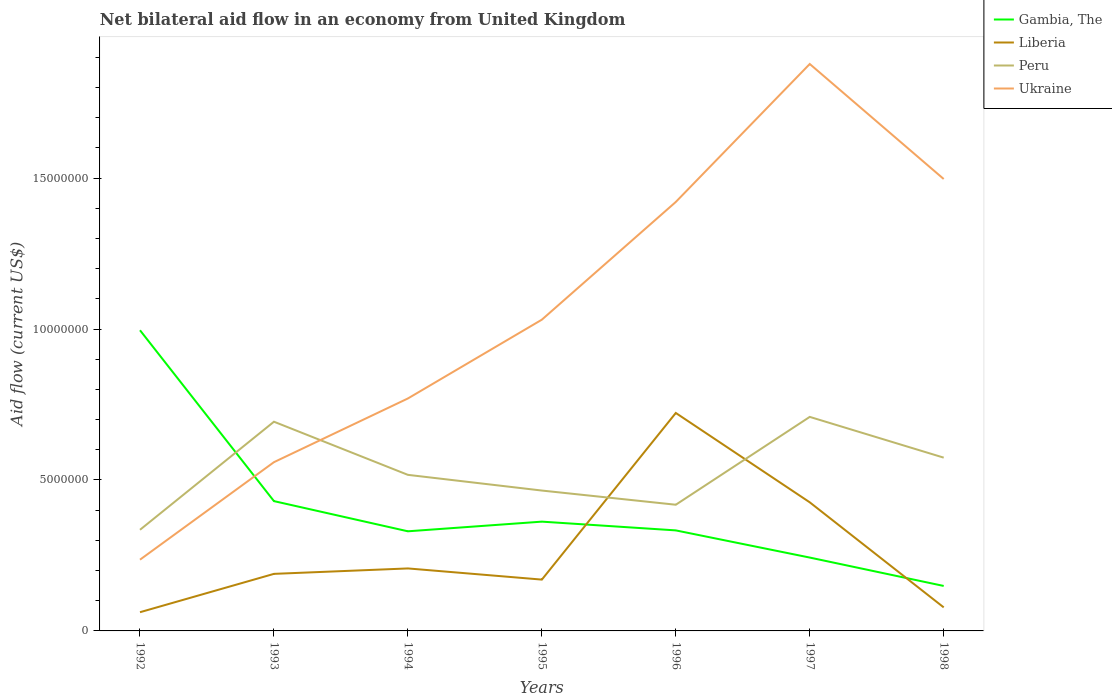Does the line corresponding to Ukraine intersect with the line corresponding to Gambia, The?
Keep it short and to the point. Yes. Across all years, what is the maximum net bilateral aid flow in Ukraine?
Make the answer very short. 2.36e+06. In which year was the net bilateral aid flow in Liberia maximum?
Keep it short and to the point. 1992. What is the total net bilateral aid flow in Liberia in the graph?
Your answer should be compact. -5.15e+06. What is the difference between the highest and the second highest net bilateral aid flow in Ukraine?
Make the answer very short. 1.64e+07. What is the difference between the highest and the lowest net bilateral aid flow in Liberia?
Provide a short and direct response. 2. Is the net bilateral aid flow in Gambia, The strictly greater than the net bilateral aid flow in Liberia over the years?
Your answer should be very brief. No. How many lines are there?
Offer a terse response. 4. Are the values on the major ticks of Y-axis written in scientific E-notation?
Make the answer very short. No. Does the graph contain any zero values?
Offer a terse response. No. How are the legend labels stacked?
Offer a terse response. Vertical. What is the title of the graph?
Offer a terse response. Net bilateral aid flow in an economy from United Kingdom. Does "Netherlands" appear as one of the legend labels in the graph?
Your response must be concise. No. What is the label or title of the Y-axis?
Give a very brief answer. Aid flow (current US$). What is the Aid flow (current US$) in Gambia, The in 1992?
Provide a succinct answer. 9.96e+06. What is the Aid flow (current US$) in Liberia in 1992?
Offer a terse response. 6.20e+05. What is the Aid flow (current US$) of Peru in 1992?
Make the answer very short. 3.35e+06. What is the Aid flow (current US$) in Ukraine in 1992?
Make the answer very short. 2.36e+06. What is the Aid flow (current US$) of Gambia, The in 1993?
Ensure brevity in your answer.  4.30e+06. What is the Aid flow (current US$) in Liberia in 1993?
Offer a terse response. 1.89e+06. What is the Aid flow (current US$) in Peru in 1993?
Offer a terse response. 6.93e+06. What is the Aid flow (current US$) in Ukraine in 1993?
Provide a short and direct response. 5.59e+06. What is the Aid flow (current US$) in Gambia, The in 1994?
Ensure brevity in your answer.  3.30e+06. What is the Aid flow (current US$) in Liberia in 1994?
Offer a terse response. 2.07e+06. What is the Aid flow (current US$) in Peru in 1994?
Give a very brief answer. 5.17e+06. What is the Aid flow (current US$) of Ukraine in 1994?
Ensure brevity in your answer.  7.70e+06. What is the Aid flow (current US$) in Gambia, The in 1995?
Give a very brief answer. 3.62e+06. What is the Aid flow (current US$) of Liberia in 1995?
Your answer should be very brief. 1.70e+06. What is the Aid flow (current US$) in Peru in 1995?
Ensure brevity in your answer.  4.65e+06. What is the Aid flow (current US$) of Ukraine in 1995?
Your answer should be very brief. 1.03e+07. What is the Aid flow (current US$) of Gambia, The in 1996?
Offer a terse response. 3.33e+06. What is the Aid flow (current US$) in Liberia in 1996?
Give a very brief answer. 7.22e+06. What is the Aid flow (current US$) in Peru in 1996?
Keep it short and to the point. 4.18e+06. What is the Aid flow (current US$) in Ukraine in 1996?
Your answer should be compact. 1.42e+07. What is the Aid flow (current US$) in Gambia, The in 1997?
Provide a short and direct response. 2.43e+06. What is the Aid flow (current US$) of Liberia in 1997?
Your answer should be very brief. 4.26e+06. What is the Aid flow (current US$) in Peru in 1997?
Ensure brevity in your answer.  7.09e+06. What is the Aid flow (current US$) in Ukraine in 1997?
Your answer should be compact. 1.88e+07. What is the Aid flow (current US$) of Gambia, The in 1998?
Provide a succinct answer. 1.49e+06. What is the Aid flow (current US$) of Liberia in 1998?
Give a very brief answer. 7.80e+05. What is the Aid flow (current US$) in Peru in 1998?
Your response must be concise. 5.74e+06. What is the Aid flow (current US$) of Ukraine in 1998?
Provide a short and direct response. 1.50e+07. Across all years, what is the maximum Aid flow (current US$) in Gambia, The?
Offer a very short reply. 9.96e+06. Across all years, what is the maximum Aid flow (current US$) of Liberia?
Make the answer very short. 7.22e+06. Across all years, what is the maximum Aid flow (current US$) of Peru?
Your answer should be very brief. 7.09e+06. Across all years, what is the maximum Aid flow (current US$) in Ukraine?
Your answer should be very brief. 1.88e+07. Across all years, what is the minimum Aid flow (current US$) of Gambia, The?
Offer a terse response. 1.49e+06. Across all years, what is the minimum Aid flow (current US$) in Liberia?
Make the answer very short. 6.20e+05. Across all years, what is the minimum Aid flow (current US$) in Peru?
Your response must be concise. 3.35e+06. Across all years, what is the minimum Aid flow (current US$) of Ukraine?
Ensure brevity in your answer.  2.36e+06. What is the total Aid flow (current US$) in Gambia, The in the graph?
Your answer should be compact. 2.84e+07. What is the total Aid flow (current US$) of Liberia in the graph?
Offer a very short reply. 1.85e+07. What is the total Aid flow (current US$) of Peru in the graph?
Your answer should be compact. 3.71e+07. What is the total Aid flow (current US$) in Ukraine in the graph?
Your answer should be compact. 7.39e+07. What is the difference between the Aid flow (current US$) in Gambia, The in 1992 and that in 1993?
Your response must be concise. 5.66e+06. What is the difference between the Aid flow (current US$) in Liberia in 1992 and that in 1993?
Offer a very short reply. -1.27e+06. What is the difference between the Aid flow (current US$) in Peru in 1992 and that in 1993?
Offer a very short reply. -3.58e+06. What is the difference between the Aid flow (current US$) in Ukraine in 1992 and that in 1993?
Offer a very short reply. -3.23e+06. What is the difference between the Aid flow (current US$) in Gambia, The in 1992 and that in 1994?
Give a very brief answer. 6.66e+06. What is the difference between the Aid flow (current US$) in Liberia in 1992 and that in 1994?
Your response must be concise. -1.45e+06. What is the difference between the Aid flow (current US$) of Peru in 1992 and that in 1994?
Provide a succinct answer. -1.82e+06. What is the difference between the Aid flow (current US$) of Ukraine in 1992 and that in 1994?
Ensure brevity in your answer.  -5.34e+06. What is the difference between the Aid flow (current US$) of Gambia, The in 1992 and that in 1995?
Give a very brief answer. 6.34e+06. What is the difference between the Aid flow (current US$) in Liberia in 1992 and that in 1995?
Provide a short and direct response. -1.08e+06. What is the difference between the Aid flow (current US$) in Peru in 1992 and that in 1995?
Offer a terse response. -1.30e+06. What is the difference between the Aid flow (current US$) of Ukraine in 1992 and that in 1995?
Offer a very short reply. -7.95e+06. What is the difference between the Aid flow (current US$) of Gambia, The in 1992 and that in 1996?
Offer a terse response. 6.63e+06. What is the difference between the Aid flow (current US$) of Liberia in 1992 and that in 1996?
Keep it short and to the point. -6.60e+06. What is the difference between the Aid flow (current US$) of Peru in 1992 and that in 1996?
Give a very brief answer. -8.30e+05. What is the difference between the Aid flow (current US$) of Ukraine in 1992 and that in 1996?
Your answer should be very brief. -1.18e+07. What is the difference between the Aid flow (current US$) of Gambia, The in 1992 and that in 1997?
Your answer should be very brief. 7.53e+06. What is the difference between the Aid flow (current US$) of Liberia in 1992 and that in 1997?
Your response must be concise. -3.64e+06. What is the difference between the Aid flow (current US$) in Peru in 1992 and that in 1997?
Keep it short and to the point. -3.74e+06. What is the difference between the Aid flow (current US$) in Ukraine in 1992 and that in 1997?
Provide a short and direct response. -1.64e+07. What is the difference between the Aid flow (current US$) of Gambia, The in 1992 and that in 1998?
Your answer should be compact. 8.47e+06. What is the difference between the Aid flow (current US$) of Peru in 1992 and that in 1998?
Your answer should be compact. -2.39e+06. What is the difference between the Aid flow (current US$) in Ukraine in 1992 and that in 1998?
Give a very brief answer. -1.26e+07. What is the difference between the Aid flow (current US$) in Peru in 1993 and that in 1994?
Your answer should be compact. 1.76e+06. What is the difference between the Aid flow (current US$) in Ukraine in 1993 and that in 1994?
Provide a short and direct response. -2.11e+06. What is the difference between the Aid flow (current US$) of Gambia, The in 1993 and that in 1995?
Give a very brief answer. 6.80e+05. What is the difference between the Aid flow (current US$) of Liberia in 1993 and that in 1995?
Give a very brief answer. 1.90e+05. What is the difference between the Aid flow (current US$) in Peru in 1993 and that in 1995?
Your answer should be very brief. 2.28e+06. What is the difference between the Aid flow (current US$) in Ukraine in 1993 and that in 1995?
Ensure brevity in your answer.  -4.72e+06. What is the difference between the Aid flow (current US$) in Gambia, The in 1993 and that in 1996?
Your response must be concise. 9.70e+05. What is the difference between the Aid flow (current US$) of Liberia in 1993 and that in 1996?
Keep it short and to the point. -5.33e+06. What is the difference between the Aid flow (current US$) in Peru in 1993 and that in 1996?
Your response must be concise. 2.75e+06. What is the difference between the Aid flow (current US$) in Ukraine in 1993 and that in 1996?
Ensure brevity in your answer.  -8.62e+06. What is the difference between the Aid flow (current US$) in Gambia, The in 1993 and that in 1997?
Offer a terse response. 1.87e+06. What is the difference between the Aid flow (current US$) of Liberia in 1993 and that in 1997?
Provide a short and direct response. -2.37e+06. What is the difference between the Aid flow (current US$) in Ukraine in 1993 and that in 1997?
Provide a succinct answer. -1.32e+07. What is the difference between the Aid flow (current US$) of Gambia, The in 1993 and that in 1998?
Your answer should be compact. 2.81e+06. What is the difference between the Aid flow (current US$) in Liberia in 1993 and that in 1998?
Make the answer very short. 1.11e+06. What is the difference between the Aid flow (current US$) in Peru in 1993 and that in 1998?
Give a very brief answer. 1.19e+06. What is the difference between the Aid flow (current US$) in Ukraine in 1993 and that in 1998?
Provide a short and direct response. -9.38e+06. What is the difference between the Aid flow (current US$) of Gambia, The in 1994 and that in 1995?
Keep it short and to the point. -3.20e+05. What is the difference between the Aid flow (current US$) in Peru in 1994 and that in 1995?
Keep it short and to the point. 5.20e+05. What is the difference between the Aid flow (current US$) of Ukraine in 1994 and that in 1995?
Keep it short and to the point. -2.61e+06. What is the difference between the Aid flow (current US$) in Gambia, The in 1994 and that in 1996?
Provide a succinct answer. -3.00e+04. What is the difference between the Aid flow (current US$) of Liberia in 1994 and that in 1996?
Offer a very short reply. -5.15e+06. What is the difference between the Aid flow (current US$) in Peru in 1994 and that in 1996?
Provide a short and direct response. 9.90e+05. What is the difference between the Aid flow (current US$) of Ukraine in 1994 and that in 1996?
Make the answer very short. -6.51e+06. What is the difference between the Aid flow (current US$) of Gambia, The in 1994 and that in 1997?
Offer a very short reply. 8.70e+05. What is the difference between the Aid flow (current US$) in Liberia in 1994 and that in 1997?
Your answer should be very brief. -2.19e+06. What is the difference between the Aid flow (current US$) in Peru in 1994 and that in 1997?
Ensure brevity in your answer.  -1.92e+06. What is the difference between the Aid flow (current US$) of Ukraine in 1994 and that in 1997?
Provide a short and direct response. -1.11e+07. What is the difference between the Aid flow (current US$) in Gambia, The in 1994 and that in 1998?
Offer a terse response. 1.81e+06. What is the difference between the Aid flow (current US$) of Liberia in 1994 and that in 1998?
Your answer should be compact. 1.29e+06. What is the difference between the Aid flow (current US$) in Peru in 1994 and that in 1998?
Provide a succinct answer. -5.70e+05. What is the difference between the Aid flow (current US$) of Ukraine in 1994 and that in 1998?
Keep it short and to the point. -7.27e+06. What is the difference between the Aid flow (current US$) in Liberia in 1995 and that in 1996?
Make the answer very short. -5.52e+06. What is the difference between the Aid flow (current US$) of Ukraine in 1995 and that in 1996?
Your answer should be very brief. -3.90e+06. What is the difference between the Aid flow (current US$) of Gambia, The in 1995 and that in 1997?
Make the answer very short. 1.19e+06. What is the difference between the Aid flow (current US$) of Liberia in 1995 and that in 1997?
Provide a short and direct response. -2.56e+06. What is the difference between the Aid flow (current US$) in Peru in 1995 and that in 1997?
Offer a very short reply. -2.44e+06. What is the difference between the Aid flow (current US$) of Ukraine in 1995 and that in 1997?
Your answer should be very brief. -8.47e+06. What is the difference between the Aid flow (current US$) of Gambia, The in 1995 and that in 1998?
Offer a very short reply. 2.13e+06. What is the difference between the Aid flow (current US$) of Liberia in 1995 and that in 1998?
Give a very brief answer. 9.20e+05. What is the difference between the Aid flow (current US$) in Peru in 1995 and that in 1998?
Offer a very short reply. -1.09e+06. What is the difference between the Aid flow (current US$) of Ukraine in 1995 and that in 1998?
Offer a very short reply. -4.66e+06. What is the difference between the Aid flow (current US$) in Liberia in 1996 and that in 1997?
Keep it short and to the point. 2.96e+06. What is the difference between the Aid flow (current US$) of Peru in 1996 and that in 1997?
Offer a terse response. -2.91e+06. What is the difference between the Aid flow (current US$) of Ukraine in 1996 and that in 1997?
Your response must be concise. -4.57e+06. What is the difference between the Aid flow (current US$) in Gambia, The in 1996 and that in 1998?
Offer a terse response. 1.84e+06. What is the difference between the Aid flow (current US$) in Liberia in 1996 and that in 1998?
Keep it short and to the point. 6.44e+06. What is the difference between the Aid flow (current US$) of Peru in 1996 and that in 1998?
Your response must be concise. -1.56e+06. What is the difference between the Aid flow (current US$) of Ukraine in 1996 and that in 1998?
Ensure brevity in your answer.  -7.60e+05. What is the difference between the Aid flow (current US$) of Gambia, The in 1997 and that in 1998?
Ensure brevity in your answer.  9.40e+05. What is the difference between the Aid flow (current US$) of Liberia in 1997 and that in 1998?
Offer a very short reply. 3.48e+06. What is the difference between the Aid flow (current US$) of Peru in 1997 and that in 1998?
Your answer should be compact. 1.35e+06. What is the difference between the Aid flow (current US$) of Ukraine in 1997 and that in 1998?
Offer a very short reply. 3.81e+06. What is the difference between the Aid flow (current US$) in Gambia, The in 1992 and the Aid flow (current US$) in Liberia in 1993?
Offer a very short reply. 8.07e+06. What is the difference between the Aid flow (current US$) of Gambia, The in 1992 and the Aid flow (current US$) of Peru in 1993?
Your response must be concise. 3.03e+06. What is the difference between the Aid flow (current US$) of Gambia, The in 1992 and the Aid flow (current US$) of Ukraine in 1993?
Your answer should be very brief. 4.37e+06. What is the difference between the Aid flow (current US$) in Liberia in 1992 and the Aid flow (current US$) in Peru in 1993?
Offer a very short reply. -6.31e+06. What is the difference between the Aid flow (current US$) of Liberia in 1992 and the Aid flow (current US$) of Ukraine in 1993?
Provide a short and direct response. -4.97e+06. What is the difference between the Aid flow (current US$) in Peru in 1992 and the Aid flow (current US$) in Ukraine in 1993?
Provide a succinct answer. -2.24e+06. What is the difference between the Aid flow (current US$) of Gambia, The in 1992 and the Aid flow (current US$) of Liberia in 1994?
Offer a very short reply. 7.89e+06. What is the difference between the Aid flow (current US$) in Gambia, The in 1992 and the Aid flow (current US$) in Peru in 1994?
Give a very brief answer. 4.79e+06. What is the difference between the Aid flow (current US$) of Gambia, The in 1992 and the Aid flow (current US$) of Ukraine in 1994?
Provide a short and direct response. 2.26e+06. What is the difference between the Aid flow (current US$) in Liberia in 1992 and the Aid flow (current US$) in Peru in 1994?
Provide a succinct answer. -4.55e+06. What is the difference between the Aid flow (current US$) in Liberia in 1992 and the Aid flow (current US$) in Ukraine in 1994?
Keep it short and to the point. -7.08e+06. What is the difference between the Aid flow (current US$) of Peru in 1992 and the Aid flow (current US$) of Ukraine in 1994?
Keep it short and to the point. -4.35e+06. What is the difference between the Aid flow (current US$) of Gambia, The in 1992 and the Aid flow (current US$) of Liberia in 1995?
Make the answer very short. 8.26e+06. What is the difference between the Aid flow (current US$) in Gambia, The in 1992 and the Aid flow (current US$) in Peru in 1995?
Your answer should be compact. 5.31e+06. What is the difference between the Aid flow (current US$) of Gambia, The in 1992 and the Aid flow (current US$) of Ukraine in 1995?
Your answer should be very brief. -3.50e+05. What is the difference between the Aid flow (current US$) in Liberia in 1992 and the Aid flow (current US$) in Peru in 1995?
Ensure brevity in your answer.  -4.03e+06. What is the difference between the Aid flow (current US$) of Liberia in 1992 and the Aid flow (current US$) of Ukraine in 1995?
Your response must be concise. -9.69e+06. What is the difference between the Aid flow (current US$) in Peru in 1992 and the Aid flow (current US$) in Ukraine in 1995?
Give a very brief answer. -6.96e+06. What is the difference between the Aid flow (current US$) of Gambia, The in 1992 and the Aid flow (current US$) of Liberia in 1996?
Your answer should be very brief. 2.74e+06. What is the difference between the Aid flow (current US$) of Gambia, The in 1992 and the Aid flow (current US$) of Peru in 1996?
Your answer should be very brief. 5.78e+06. What is the difference between the Aid flow (current US$) of Gambia, The in 1992 and the Aid flow (current US$) of Ukraine in 1996?
Offer a very short reply. -4.25e+06. What is the difference between the Aid flow (current US$) of Liberia in 1992 and the Aid flow (current US$) of Peru in 1996?
Your answer should be compact. -3.56e+06. What is the difference between the Aid flow (current US$) in Liberia in 1992 and the Aid flow (current US$) in Ukraine in 1996?
Your response must be concise. -1.36e+07. What is the difference between the Aid flow (current US$) of Peru in 1992 and the Aid flow (current US$) of Ukraine in 1996?
Make the answer very short. -1.09e+07. What is the difference between the Aid flow (current US$) in Gambia, The in 1992 and the Aid flow (current US$) in Liberia in 1997?
Offer a terse response. 5.70e+06. What is the difference between the Aid flow (current US$) in Gambia, The in 1992 and the Aid flow (current US$) in Peru in 1997?
Offer a terse response. 2.87e+06. What is the difference between the Aid flow (current US$) in Gambia, The in 1992 and the Aid flow (current US$) in Ukraine in 1997?
Your answer should be very brief. -8.82e+06. What is the difference between the Aid flow (current US$) in Liberia in 1992 and the Aid flow (current US$) in Peru in 1997?
Keep it short and to the point. -6.47e+06. What is the difference between the Aid flow (current US$) in Liberia in 1992 and the Aid flow (current US$) in Ukraine in 1997?
Provide a short and direct response. -1.82e+07. What is the difference between the Aid flow (current US$) of Peru in 1992 and the Aid flow (current US$) of Ukraine in 1997?
Your answer should be compact. -1.54e+07. What is the difference between the Aid flow (current US$) of Gambia, The in 1992 and the Aid flow (current US$) of Liberia in 1998?
Keep it short and to the point. 9.18e+06. What is the difference between the Aid flow (current US$) of Gambia, The in 1992 and the Aid flow (current US$) of Peru in 1998?
Your answer should be compact. 4.22e+06. What is the difference between the Aid flow (current US$) in Gambia, The in 1992 and the Aid flow (current US$) in Ukraine in 1998?
Provide a short and direct response. -5.01e+06. What is the difference between the Aid flow (current US$) of Liberia in 1992 and the Aid flow (current US$) of Peru in 1998?
Make the answer very short. -5.12e+06. What is the difference between the Aid flow (current US$) of Liberia in 1992 and the Aid flow (current US$) of Ukraine in 1998?
Your answer should be very brief. -1.44e+07. What is the difference between the Aid flow (current US$) in Peru in 1992 and the Aid flow (current US$) in Ukraine in 1998?
Keep it short and to the point. -1.16e+07. What is the difference between the Aid flow (current US$) of Gambia, The in 1993 and the Aid flow (current US$) of Liberia in 1994?
Provide a short and direct response. 2.23e+06. What is the difference between the Aid flow (current US$) in Gambia, The in 1993 and the Aid flow (current US$) in Peru in 1994?
Give a very brief answer. -8.70e+05. What is the difference between the Aid flow (current US$) of Gambia, The in 1993 and the Aid flow (current US$) of Ukraine in 1994?
Offer a terse response. -3.40e+06. What is the difference between the Aid flow (current US$) of Liberia in 1993 and the Aid flow (current US$) of Peru in 1994?
Offer a terse response. -3.28e+06. What is the difference between the Aid flow (current US$) of Liberia in 1993 and the Aid flow (current US$) of Ukraine in 1994?
Ensure brevity in your answer.  -5.81e+06. What is the difference between the Aid flow (current US$) in Peru in 1993 and the Aid flow (current US$) in Ukraine in 1994?
Your answer should be very brief. -7.70e+05. What is the difference between the Aid flow (current US$) in Gambia, The in 1993 and the Aid flow (current US$) in Liberia in 1995?
Ensure brevity in your answer.  2.60e+06. What is the difference between the Aid flow (current US$) of Gambia, The in 1993 and the Aid flow (current US$) of Peru in 1995?
Offer a very short reply. -3.50e+05. What is the difference between the Aid flow (current US$) of Gambia, The in 1993 and the Aid flow (current US$) of Ukraine in 1995?
Offer a terse response. -6.01e+06. What is the difference between the Aid flow (current US$) in Liberia in 1993 and the Aid flow (current US$) in Peru in 1995?
Your answer should be very brief. -2.76e+06. What is the difference between the Aid flow (current US$) of Liberia in 1993 and the Aid flow (current US$) of Ukraine in 1995?
Your answer should be compact. -8.42e+06. What is the difference between the Aid flow (current US$) in Peru in 1993 and the Aid flow (current US$) in Ukraine in 1995?
Provide a succinct answer. -3.38e+06. What is the difference between the Aid flow (current US$) of Gambia, The in 1993 and the Aid flow (current US$) of Liberia in 1996?
Offer a very short reply. -2.92e+06. What is the difference between the Aid flow (current US$) in Gambia, The in 1993 and the Aid flow (current US$) in Peru in 1996?
Your answer should be compact. 1.20e+05. What is the difference between the Aid flow (current US$) of Gambia, The in 1993 and the Aid flow (current US$) of Ukraine in 1996?
Offer a terse response. -9.91e+06. What is the difference between the Aid flow (current US$) in Liberia in 1993 and the Aid flow (current US$) in Peru in 1996?
Make the answer very short. -2.29e+06. What is the difference between the Aid flow (current US$) of Liberia in 1993 and the Aid flow (current US$) of Ukraine in 1996?
Offer a terse response. -1.23e+07. What is the difference between the Aid flow (current US$) of Peru in 1993 and the Aid flow (current US$) of Ukraine in 1996?
Your answer should be compact. -7.28e+06. What is the difference between the Aid flow (current US$) in Gambia, The in 1993 and the Aid flow (current US$) in Peru in 1997?
Offer a terse response. -2.79e+06. What is the difference between the Aid flow (current US$) in Gambia, The in 1993 and the Aid flow (current US$) in Ukraine in 1997?
Offer a terse response. -1.45e+07. What is the difference between the Aid flow (current US$) in Liberia in 1993 and the Aid flow (current US$) in Peru in 1997?
Offer a very short reply. -5.20e+06. What is the difference between the Aid flow (current US$) in Liberia in 1993 and the Aid flow (current US$) in Ukraine in 1997?
Your answer should be very brief. -1.69e+07. What is the difference between the Aid flow (current US$) in Peru in 1993 and the Aid flow (current US$) in Ukraine in 1997?
Provide a short and direct response. -1.18e+07. What is the difference between the Aid flow (current US$) of Gambia, The in 1993 and the Aid flow (current US$) of Liberia in 1998?
Provide a succinct answer. 3.52e+06. What is the difference between the Aid flow (current US$) of Gambia, The in 1993 and the Aid flow (current US$) of Peru in 1998?
Your answer should be very brief. -1.44e+06. What is the difference between the Aid flow (current US$) of Gambia, The in 1993 and the Aid flow (current US$) of Ukraine in 1998?
Keep it short and to the point. -1.07e+07. What is the difference between the Aid flow (current US$) in Liberia in 1993 and the Aid flow (current US$) in Peru in 1998?
Ensure brevity in your answer.  -3.85e+06. What is the difference between the Aid flow (current US$) of Liberia in 1993 and the Aid flow (current US$) of Ukraine in 1998?
Ensure brevity in your answer.  -1.31e+07. What is the difference between the Aid flow (current US$) of Peru in 1993 and the Aid flow (current US$) of Ukraine in 1998?
Offer a terse response. -8.04e+06. What is the difference between the Aid flow (current US$) in Gambia, The in 1994 and the Aid flow (current US$) in Liberia in 1995?
Give a very brief answer. 1.60e+06. What is the difference between the Aid flow (current US$) in Gambia, The in 1994 and the Aid flow (current US$) in Peru in 1995?
Provide a short and direct response. -1.35e+06. What is the difference between the Aid flow (current US$) of Gambia, The in 1994 and the Aid flow (current US$) of Ukraine in 1995?
Provide a short and direct response. -7.01e+06. What is the difference between the Aid flow (current US$) in Liberia in 1994 and the Aid flow (current US$) in Peru in 1995?
Offer a terse response. -2.58e+06. What is the difference between the Aid flow (current US$) in Liberia in 1994 and the Aid flow (current US$) in Ukraine in 1995?
Make the answer very short. -8.24e+06. What is the difference between the Aid flow (current US$) in Peru in 1994 and the Aid flow (current US$) in Ukraine in 1995?
Your response must be concise. -5.14e+06. What is the difference between the Aid flow (current US$) of Gambia, The in 1994 and the Aid flow (current US$) of Liberia in 1996?
Provide a succinct answer. -3.92e+06. What is the difference between the Aid flow (current US$) of Gambia, The in 1994 and the Aid flow (current US$) of Peru in 1996?
Your answer should be very brief. -8.80e+05. What is the difference between the Aid flow (current US$) of Gambia, The in 1994 and the Aid flow (current US$) of Ukraine in 1996?
Keep it short and to the point. -1.09e+07. What is the difference between the Aid flow (current US$) of Liberia in 1994 and the Aid flow (current US$) of Peru in 1996?
Keep it short and to the point. -2.11e+06. What is the difference between the Aid flow (current US$) in Liberia in 1994 and the Aid flow (current US$) in Ukraine in 1996?
Offer a terse response. -1.21e+07. What is the difference between the Aid flow (current US$) of Peru in 1994 and the Aid flow (current US$) of Ukraine in 1996?
Ensure brevity in your answer.  -9.04e+06. What is the difference between the Aid flow (current US$) in Gambia, The in 1994 and the Aid flow (current US$) in Liberia in 1997?
Provide a short and direct response. -9.60e+05. What is the difference between the Aid flow (current US$) of Gambia, The in 1994 and the Aid flow (current US$) of Peru in 1997?
Your answer should be very brief. -3.79e+06. What is the difference between the Aid flow (current US$) in Gambia, The in 1994 and the Aid flow (current US$) in Ukraine in 1997?
Your response must be concise. -1.55e+07. What is the difference between the Aid flow (current US$) of Liberia in 1994 and the Aid flow (current US$) of Peru in 1997?
Your answer should be very brief. -5.02e+06. What is the difference between the Aid flow (current US$) of Liberia in 1994 and the Aid flow (current US$) of Ukraine in 1997?
Your answer should be very brief. -1.67e+07. What is the difference between the Aid flow (current US$) of Peru in 1994 and the Aid flow (current US$) of Ukraine in 1997?
Your answer should be compact. -1.36e+07. What is the difference between the Aid flow (current US$) of Gambia, The in 1994 and the Aid flow (current US$) of Liberia in 1998?
Ensure brevity in your answer.  2.52e+06. What is the difference between the Aid flow (current US$) of Gambia, The in 1994 and the Aid flow (current US$) of Peru in 1998?
Your response must be concise. -2.44e+06. What is the difference between the Aid flow (current US$) of Gambia, The in 1994 and the Aid flow (current US$) of Ukraine in 1998?
Your response must be concise. -1.17e+07. What is the difference between the Aid flow (current US$) of Liberia in 1994 and the Aid flow (current US$) of Peru in 1998?
Provide a succinct answer. -3.67e+06. What is the difference between the Aid flow (current US$) of Liberia in 1994 and the Aid flow (current US$) of Ukraine in 1998?
Make the answer very short. -1.29e+07. What is the difference between the Aid flow (current US$) in Peru in 1994 and the Aid flow (current US$) in Ukraine in 1998?
Your response must be concise. -9.80e+06. What is the difference between the Aid flow (current US$) of Gambia, The in 1995 and the Aid flow (current US$) of Liberia in 1996?
Keep it short and to the point. -3.60e+06. What is the difference between the Aid flow (current US$) in Gambia, The in 1995 and the Aid flow (current US$) in Peru in 1996?
Ensure brevity in your answer.  -5.60e+05. What is the difference between the Aid flow (current US$) in Gambia, The in 1995 and the Aid flow (current US$) in Ukraine in 1996?
Keep it short and to the point. -1.06e+07. What is the difference between the Aid flow (current US$) in Liberia in 1995 and the Aid flow (current US$) in Peru in 1996?
Provide a short and direct response. -2.48e+06. What is the difference between the Aid flow (current US$) in Liberia in 1995 and the Aid flow (current US$) in Ukraine in 1996?
Offer a very short reply. -1.25e+07. What is the difference between the Aid flow (current US$) of Peru in 1995 and the Aid flow (current US$) of Ukraine in 1996?
Make the answer very short. -9.56e+06. What is the difference between the Aid flow (current US$) of Gambia, The in 1995 and the Aid flow (current US$) of Liberia in 1997?
Provide a succinct answer. -6.40e+05. What is the difference between the Aid flow (current US$) of Gambia, The in 1995 and the Aid flow (current US$) of Peru in 1997?
Offer a terse response. -3.47e+06. What is the difference between the Aid flow (current US$) of Gambia, The in 1995 and the Aid flow (current US$) of Ukraine in 1997?
Your answer should be compact. -1.52e+07. What is the difference between the Aid flow (current US$) in Liberia in 1995 and the Aid flow (current US$) in Peru in 1997?
Provide a succinct answer. -5.39e+06. What is the difference between the Aid flow (current US$) in Liberia in 1995 and the Aid flow (current US$) in Ukraine in 1997?
Offer a terse response. -1.71e+07. What is the difference between the Aid flow (current US$) in Peru in 1995 and the Aid flow (current US$) in Ukraine in 1997?
Offer a very short reply. -1.41e+07. What is the difference between the Aid flow (current US$) of Gambia, The in 1995 and the Aid flow (current US$) of Liberia in 1998?
Make the answer very short. 2.84e+06. What is the difference between the Aid flow (current US$) in Gambia, The in 1995 and the Aid flow (current US$) in Peru in 1998?
Ensure brevity in your answer.  -2.12e+06. What is the difference between the Aid flow (current US$) in Gambia, The in 1995 and the Aid flow (current US$) in Ukraine in 1998?
Keep it short and to the point. -1.14e+07. What is the difference between the Aid flow (current US$) of Liberia in 1995 and the Aid flow (current US$) of Peru in 1998?
Ensure brevity in your answer.  -4.04e+06. What is the difference between the Aid flow (current US$) in Liberia in 1995 and the Aid flow (current US$) in Ukraine in 1998?
Your answer should be compact. -1.33e+07. What is the difference between the Aid flow (current US$) in Peru in 1995 and the Aid flow (current US$) in Ukraine in 1998?
Offer a terse response. -1.03e+07. What is the difference between the Aid flow (current US$) in Gambia, The in 1996 and the Aid flow (current US$) in Liberia in 1997?
Make the answer very short. -9.30e+05. What is the difference between the Aid flow (current US$) of Gambia, The in 1996 and the Aid flow (current US$) of Peru in 1997?
Give a very brief answer. -3.76e+06. What is the difference between the Aid flow (current US$) in Gambia, The in 1996 and the Aid flow (current US$) in Ukraine in 1997?
Offer a terse response. -1.54e+07. What is the difference between the Aid flow (current US$) in Liberia in 1996 and the Aid flow (current US$) in Ukraine in 1997?
Ensure brevity in your answer.  -1.16e+07. What is the difference between the Aid flow (current US$) of Peru in 1996 and the Aid flow (current US$) of Ukraine in 1997?
Your response must be concise. -1.46e+07. What is the difference between the Aid flow (current US$) in Gambia, The in 1996 and the Aid flow (current US$) in Liberia in 1998?
Your response must be concise. 2.55e+06. What is the difference between the Aid flow (current US$) of Gambia, The in 1996 and the Aid flow (current US$) of Peru in 1998?
Ensure brevity in your answer.  -2.41e+06. What is the difference between the Aid flow (current US$) of Gambia, The in 1996 and the Aid flow (current US$) of Ukraine in 1998?
Offer a terse response. -1.16e+07. What is the difference between the Aid flow (current US$) of Liberia in 1996 and the Aid flow (current US$) of Peru in 1998?
Make the answer very short. 1.48e+06. What is the difference between the Aid flow (current US$) of Liberia in 1996 and the Aid flow (current US$) of Ukraine in 1998?
Offer a terse response. -7.75e+06. What is the difference between the Aid flow (current US$) in Peru in 1996 and the Aid flow (current US$) in Ukraine in 1998?
Keep it short and to the point. -1.08e+07. What is the difference between the Aid flow (current US$) in Gambia, The in 1997 and the Aid flow (current US$) in Liberia in 1998?
Your response must be concise. 1.65e+06. What is the difference between the Aid flow (current US$) in Gambia, The in 1997 and the Aid flow (current US$) in Peru in 1998?
Provide a short and direct response. -3.31e+06. What is the difference between the Aid flow (current US$) of Gambia, The in 1997 and the Aid flow (current US$) of Ukraine in 1998?
Provide a short and direct response. -1.25e+07. What is the difference between the Aid flow (current US$) in Liberia in 1997 and the Aid flow (current US$) in Peru in 1998?
Give a very brief answer. -1.48e+06. What is the difference between the Aid flow (current US$) of Liberia in 1997 and the Aid flow (current US$) of Ukraine in 1998?
Your response must be concise. -1.07e+07. What is the difference between the Aid flow (current US$) of Peru in 1997 and the Aid flow (current US$) of Ukraine in 1998?
Provide a short and direct response. -7.88e+06. What is the average Aid flow (current US$) in Gambia, The per year?
Make the answer very short. 4.06e+06. What is the average Aid flow (current US$) in Liberia per year?
Ensure brevity in your answer.  2.65e+06. What is the average Aid flow (current US$) in Peru per year?
Your answer should be very brief. 5.30e+06. What is the average Aid flow (current US$) in Ukraine per year?
Ensure brevity in your answer.  1.06e+07. In the year 1992, what is the difference between the Aid flow (current US$) in Gambia, The and Aid flow (current US$) in Liberia?
Offer a very short reply. 9.34e+06. In the year 1992, what is the difference between the Aid flow (current US$) of Gambia, The and Aid flow (current US$) of Peru?
Make the answer very short. 6.61e+06. In the year 1992, what is the difference between the Aid flow (current US$) in Gambia, The and Aid flow (current US$) in Ukraine?
Offer a terse response. 7.60e+06. In the year 1992, what is the difference between the Aid flow (current US$) in Liberia and Aid flow (current US$) in Peru?
Ensure brevity in your answer.  -2.73e+06. In the year 1992, what is the difference between the Aid flow (current US$) in Liberia and Aid flow (current US$) in Ukraine?
Provide a succinct answer. -1.74e+06. In the year 1992, what is the difference between the Aid flow (current US$) of Peru and Aid flow (current US$) of Ukraine?
Give a very brief answer. 9.90e+05. In the year 1993, what is the difference between the Aid flow (current US$) of Gambia, The and Aid flow (current US$) of Liberia?
Offer a terse response. 2.41e+06. In the year 1993, what is the difference between the Aid flow (current US$) of Gambia, The and Aid flow (current US$) of Peru?
Your answer should be compact. -2.63e+06. In the year 1993, what is the difference between the Aid flow (current US$) in Gambia, The and Aid flow (current US$) in Ukraine?
Your response must be concise. -1.29e+06. In the year 1993, what is the difference between the Aid flow (current US$) in Liberia and Aid flow (current US$) in Peru?
Make the answer very short. -5.04e+06. In the year 1993, what is the difference between the Aid flow (current US$) in Liberia and Aid flow (current US$) in Ukraine?
Ensure brevity in your answer.  -3.70e+06. In the year 1993, what is the difference between the Aid flow (current US$) in Peru and Aid flow (current US$) in Ukraine?
Offer a very short reply. 1.34e+06. In the year 1994, what is the difference between the Aid flow (current US$) in Gambia, The and Aid flow (current US$) in Liberia?
Provide a succinct answer. 1.23e+06. In the year 1994, what is the difference between the Aid flow (current US$) of Gambia, The and Aid flow (current US$) of Peru?
Offer a very short reply. -1.87e+06. In the year 1994, what is the difference between the Aid flow (current US$) of Gambia, The and Aid flow (current US$) of Ukraine?
Your response must be concise. -4.40e+06. In the year 1994, what is the difference between the Aid flow (current US$) of Liberia and Aid flow (current US$) of Peru?
Offer a very short reply. -3.10e+06. In the year 1994, what is the difference between the Aid flow (current US$) in Liberia and Aid flow (current US$) in Ukraine?
Offer a very short reply. -5.63e+06. In the year 1994, what is the difference between the Aid flow (current US$) of Peru and Aid flow (current US$) of Ukraine?
Give a very brief answer. -2.53e+06. In the year 1995, what is the difference between the Aid flow (current US$) in Gambia, The and Aid flow (current US$) in Liberia?
Provide a short and direct response. 1.92e+06. In the year 1995, what is the difference between the Aid flow (current US$) in Gambia, The and Aid flow (current US$) in Peru?
Offer a terse response. -1.03e+06. In the year 1995, what is the difference between the Aid flow (current US$) of Gambia, The and Aid flow (current US$) of Ukraine?
Keep it short and to the point. -6.69e+06. In the year 1995, what is the difference between the Aid flow (current US$) of Liberia and Aid flow (current US$) of Peru?
Your answer should be compact. -2.95e+06. In the year 1995, what is the difference between the Aid flow (current US$) in Liberia and Aid flow (current US$) in Ukraine?
Provide a succinct answer. -8.61e+06. In the year 1995, what is the difference between the Aid flow (current US$) in Peru and Aid flow (current US$) in Ukraine?
Your answer should be compact. -5.66e+06. In the year 1996, what is the difference between the Aid flow (current US$) of Gambia, The and Aid flow (current US$) of Liberia?
Your answer should be very brief. -3.89e+06. In the year 1996, what is the difference between the Aid flow (current US$) in Gambia, The and Aid flow (current US$) in Peru?
Make the answer very short. -8.50e+05. In the year 1996, what is the difference between the Aid flow (current US$) of Gambia, The and Aid flow (current US$) of Ukraine?
Make the answer very short. -1.09e+07. In the year 1996, what is the difference between the Aid flow (current US$) of Liberia and Aid flow (current US$) of Peru?
Offer a very short reply. 3.04e+06. In the year 1996, what is the difference between the Aid flow (current US$) of Liberia and Aid flow (current US$) of Ukraine?
Your answer should be very brief. -6.99e+06. In the year 1996, what is the difference between the Aid flow (current US$) in Peru and Aid flow (current US$) in Ukraine?
Your answer should be compact. -1.00e+07. In the year 1997, what is the difference between the Aid flow (current US$) in Gambia, The and Aid flow (current US$) in Liberia?
Provide a succinct answer. -1.83e+06. In the year 1997, what is the difference between the Aid flow (current US$) of Gambia, The and Aid flow (current US$) of Peru?
Offer a very short reply. -4.66e+06. In the year 1997, what is the difference between the Aid flow (current US$) of Gambia, The and Aid flow (current US$) of Ukraine?
Provide a succinct answer. -1.64e+07. In the year 1997, what is the difference between the Aid flow (current US$) of Liberia and Aid flow (current US$) of Peru?
Provide a short and direct response. -2.83e+06. In the year 1997, what is the difference between the Aid flow (current US$) in Liberia and Aid flow (current US$) in Ukraine?
Give a very brief answer. -1.45e+07. In the year 1997, what is the difference between the Aid flow (current US$) in Peru and Aid flow (current US$) in Ukraine?
Your response must be concise. -1.17e+07. In the year 1998, what is the difference between the Aid flow (current US$) in Gambia, The and Aid flow (current US$) in Liberia?
Offer a very short reply. 7.10e+05. In the year 1998, what is the difference between the Aid flow (current US$) in Gambia, The and Aid flow (current US$) in Peru?
Make the answer very short. -4.25e+06. In the year 1998, what is the difference between the Aid flow (current US$) of Gambia, The and Aid flow (current US$) of Ukraine?
Make the answer very short. -1.35e+07. In the year 1998, what is the difference between the Aid flow (current US$) of Liberia and Aid flow (current US$) of Peru?
Provide a succinct answer. -4.96e+06. In the year 1998, what is the difference between the Aid flow (current US$) in Liberia and Aid flow (current US$) in Ukraine?
Your answer should be very brief. -1.42e+07. In the year 1998, what is the difference between the Aid flow (current US$) in Peru and Aid flow (current US$) in Ukraine?
Give a very brief answer. -9.23e+06. What is the ratio of the Aid flow (current US$) in Gambia, The in 1992 to that in 1993?
Offer a terse response. 2.32. What is the ratio of the Aid flow (current US$) of Liberia in 1992 to that in 1993?
Your answer should be compact. 0.33. What is the ratio of the Aid flow (current US$) of Peru in 1992 to that in 1993?
Ensure brevity in your answer.  0.48. What is the ratio of the Aid flow (current US$) in Ukraine in 1992 to that in 1993?
Keep it short and to the point. 0.42. What is the ratio of the Aid flow (current US$) in Gambia, The in 1992 to that in 1994?
Your answer should be very brief. 3.02. What is the ratio of the Aid flow (current US$) in Liberia in 1992 to that in 1994?
Your response must be concise. 0.3. What is the ratio of the Aid flow (current US$) in Peru in 1992 to that in 1994?
Your answer should be compact. 0.65. What is the ratio of the Aid flow (current US$) in Ukraine in 1992 to that in 1994?
Your response must be concise. 0.31. What is the ratio of the Aid flow (current US$) of Gambia, The in 1992 to that in 1995?
Your answer should be compact. 2.75. What is the ratio of the Aid flow (current US$) in Liberia in 1992 to that in 1995?
Your answer should be very brief. 0.36. What is the ratio of the Aid flow (current US$) of Peru in 1992 to that in 1995?
Offer a very short reply. 0.72. What is the ratio of the Aid flow (current US$) of Ukraine in 1992 to that in 1995?
Ensure brevity in your answer.  0.23. What is the ratio of the Aid flow (current US$) in Gambia, The in 1992 to that in 1996?
Offer a terse response. 2.99. What is the ratio of the Aid flow (current US$) in Liberia in 1992 to that in 1996?
Offer a very short reply. 0.09. What is the ratio of the Aid flow (current US$) of Peru in 1992 to that in 1996?
Make the answer very short. 0.8. What is the ratio of the Aid flow (current US$) in Ukraine in 1992 to that in 1996?
Provide a short and direct response. 0.17. What is the ratio of the Aid flow (current US$) of Gambia, The in 1992 to that in 1997?
Make the answer very short. 4.1. What is the ratio of the Aid flow (current US$) of Liberia in 1992 to that in 1997?
Make the answer very short. 0.15. What is the ratio of the Aid flow (current US$) of Peru in 1992 to that in 1997?
Offer a terse response. 0.47. What is the ratio of the Aid flow (current US$) of Ukraine in 1992 to that in 1997?
Offer a terse response. 0.13. What is the ratio of the Aid flow (current US$) of Gambia, The in 1992 to that in 1998?
Offer a very short reply. 6.68. What is the ratio of the Aid flow (current US$) of Liberia in 1992 to that in 1998?
Your response must be concise. 0.79. What is the ratio of the Aid flow (current US$) in Peru in 1992 to that in 1998?
Your answer should be very brief. 0.58. What is the ratio of the Aid flow (current US$) in Ukraine in 1992 to that in 1998?
Your answer should be very brief. 0.16. What is the ratio of the Aid flow (current US$) in Gambia, The in 1993 to that in 1994?
Offer a terse response. 1.3. What is the ratio of the Aid flow (current US$) in Liberia in 1993 to that in 1994?
Offer a terse response. 0.91. What is the ratio of the Aid flow (current US$) of Peru in 1993 to that in 1994?
Offer a very short reply. 1.34. What is the ratio of the Aid flow (current US$) in Ukraine in 1993 to that in 1994?
Your response must be concise. 0.73. What is the ratio of the Aid flow (current US$) of Gambia, The in 1993 to that in 1995?
Ensure brevity in your answer.  1.19. What is the ratio of the Aid flow (current US$) in Liberia in 1993 to that in 1995?
Ensure brevity in your answer.  1.11. What is the ratio of the Aid flow (current US$) in Peru in 1993 to that in 1995?
Offer a terse response. 1.49. What is the ratio of the Aid flow (current US$) of Ukraine in 1993 to that in 1995?
Offer a very short reply. 0.54. What is the ratio of the Aid flow (current US$) in Gambia, The in 1993 to that in 1996?
Your answer should be very brief. 1.29. What is the ratio of the Aid flow (current US$) of Liberia in 1993 to that in 1996?
Give a very brief answer. 0.26. What is the ratio of the Aid flow (current US$) of Peru in 1993 to that in 1996?
Provide a succinct answer. 1.66. What is the ratio of the Aid flow (current US$) of Ukraine in 1993 to that in 1996?
Your answer should be compact. 0.39. What is the ratio of the Aid flow (current US$) of Gambia, The in 1993 to that in 1997?
Provide a short and direct response. 1.77. What is the ratio of the Aid flow (current US$) of Liberia in 1993 to that in 1997?
Ensure brevity in your answer.  0.44. What is the ratio of the Aid flow (current US$) in Peru in 1993 to that in 1997?
Offer a very short reply. 0.98. What is the ratio of the Aid flow (current US$) in Ukraine in 1993 to that in 1997?
Provide a short and direct response. 0.3. What is the ratio of the Aid flow (current US$) in Gambia, The in 1993 to that in 1998?
Provide a succinct answer. 2.89. What is the ratio of the Aid flow (current US$) of Liberia in 1993 to that in 1998?
Offer a very short reply. 2.42. What is the ratio of the Aid flow (current US$) in Peru in 1993 to that in 1998?
Provide a short and direct response. 1.21. What is the ratio of the Aid flow (current US$) in Ukraine in 1993 to that in 1998?
Ensure brevity in your answer.  0.37. What is the ratio of the Aid flow (current US$) in Gambia, The in 1994 to that in 1995?
Give a very brief answer. 0.91. What is the ratio of the Aid flow (current US$) of Liberia in 1994 to that in 1995?
Offer a terse response. 1.22. What is the ratio of the Aid flow (current US$) of Peru in 1994 to that in 1995?
Your answer should be very brief. 1.11. What is the ratio of the Aid flow (current US$) of Ukraine in 1994 to that in 1995?
Provide a short and direct response. 0.75. What is the ratio of the Aid flow (current US$) of Liberia in 1994 to that in 1996?
Keep it short and to the point. 0.29. What is the ratio of the Aid flow (current US$) in Peru in 1994 to that in 1996?
Give a very brief answer. 1.24. What is the ratio of the Aid flow (current US$) in Ukraine in 1994 to that in 1996?
Your response must be concise. 0.54. What is the ratio of the Aid flow (current US$) in Gambia, The in 1994 to that in 1997?
Your answer should be compact. 1.36. What is the ratio of the Aid flow (current US$) of Liberia in 1994 to that in 1997?
Keep it short and to the point. 0.49. What is the ratio of the Aid flow (current US$) of Peru in 1994 to that in 1997?
Keep it short and to the point. 0.73. What is the ratio of the Aid flow (current US$) in Ukraine in 1994 to that in 1997?
Ensure brevity in your answer.  0.41. What is the ratio of the Aid flow (current US$) of Gambia, The in 1994 to that in 1998?
Offer a terse response. 2.21. What is the ratio of the Aid flow (current US$) of Liberia in 1994 to that in 1998?
Your answer should be compact. 2.65. What is the ratio of the Aid flow (current US$) of Peru in 1994 to that in 1998?
Ensure brevity in your answer.  0.9. What is the ratio of the Aid flow (current US$) in Ukraine in 1994 to that in 1998?
Your answer should be very brief. 0.51. What is the ratio of the Aid flow (current US$) in Gambia, The in 1995 to that in 1996?
Offer a very short reply. 1.09. What is the ratio of the Aid flow (current US$) in Liberia in 1995 to that in 1996?
Provide a succinct answer. 0.24. What is the ratio of the Aid flow (current US$) of Peru in 1995 to that in 1996?
Offer a terse response. 1.11. What is the ratio of the Aid flow (current US$) in Ukraine in 1995 to that in 1996?
Offer a very short reply. 0.73. What is the ratio of the Aid flow (current US$) in Gambia, The in 1995 to that in 1997?
Give a very brief answer. 1.49. What is the ratio of the Aid flow (current US$) in Liberia in 1995 to that in 1997?
Ensure brevity in your answer.  0.4. What is the ratio of the Aid flow (current US$) in Peru in 1995 to that in 1997?
Your answer should be very brief. 0.66. What is the ratio of the Aid flow (current US$) in Ukraine in 1995 to that in 1997?
Offer a very short reply. 0.55. What is the ratio of the Aid flow (current US$) of Gambia, The in 1995 to that in 1998?
Your answer should be compact. 2.43. What is the ratio of the Aid flow (current US$) of Liberia in 1995 to that in 1998?
Keep it short and to the point. 2.18. What is the ratio of the Aid flow (current US$) in Peru in 1995 to that in 1998?
Make the answer very short. 0.81. What is the ratio of the Aid flow (current US$) in Ukraine in 1995 to that in 1998?
Provide a short and direct response. 0.69. What is the ratio of the Aid flow (current US$) in Gambia, The in 1996 to that in 1997?
Your response must be concise. 1.37. What is the ratio of the Aid flow (current US$) of Liberia in 1996 to that in 1997?
Your response must be concise. 1.69. What is the ratio of the Aid flow (current US$) in Peru in 1996 to that in 1997?
Offer a terse response. 0.59. What is the ratio of the Aid flow (current US$) of Ukraine in 1996 to that in 1997?
Provide a succinct answer. 0.76. What is the ratio of the Aid flow (current US$) of Gambia, The in 1996 to that in 1998?
Provide a succinct answer. 2.23. What is the ratio of the Aid flow (current US$) in Liberia in 1996 to that in 1998?
Provide a short and direct response. 9.26. What is the ratio of the Aid flow (current US$) of Peru in 1996 to that in 1998?
Ensure brevity in your answer.  0.73. What is the ratio of the Aid flow (current US$) of Ukraine in 1996 to that in 1998?
Keep it short and to the point. 0.95. What is the ratio of the Aid flow (current US$) of Gambia, The in 1997 to that in 1998?
Offer a terse response. 1.63. What is the ratio of the Aid flow (current US$) of Liberia in 1997 to that in 1998?
Your answer should be compact. 5.46. What is the ratio of the Aid flow (current US$) in Peru in 1997 to that in 1998?
Ensure brevity in your answer.  1.24. What is the ratio of the Aid flow (current US$) of Ukraine in 1997 to that in 1998?
Make the answer very short. 1.25. What is the difference between the highest and the second highest Aid flow (current US$) of Gambia, The?
Your answer should be compact. 5.66e+06. What is the difference between the highest and the second highest Aid flow (current US$) of Liberia?
Your answer should be compact. 2.96e+06. What is the difference between the highest and the second highest Aid flow (current US$) in Peru?
Keep it short and to the point. 1.60e+05. What is the difference between the highest and the second highest Aid flow (current US$) of Ukraine?
Make the answer very short. 3.81e+06. What is the difference between the highest and the lowest Aid flow (current US$) of Gambia, The?
Your answer should be compact. 8.47e+06. What is the difference between the highest and the lowest Aid flow (current US$) of Liberia?
Your answer should be very brief. 6.60e+06. What is the difference between the highest and the lowest Aid flow (current US$) in Peru?
Give a very brief answer. 3.74e+06. What is the difference between the highest and the lowest Aid flow (current US$) in Ukraine?
Offer a terse response. 1.64e+07. 